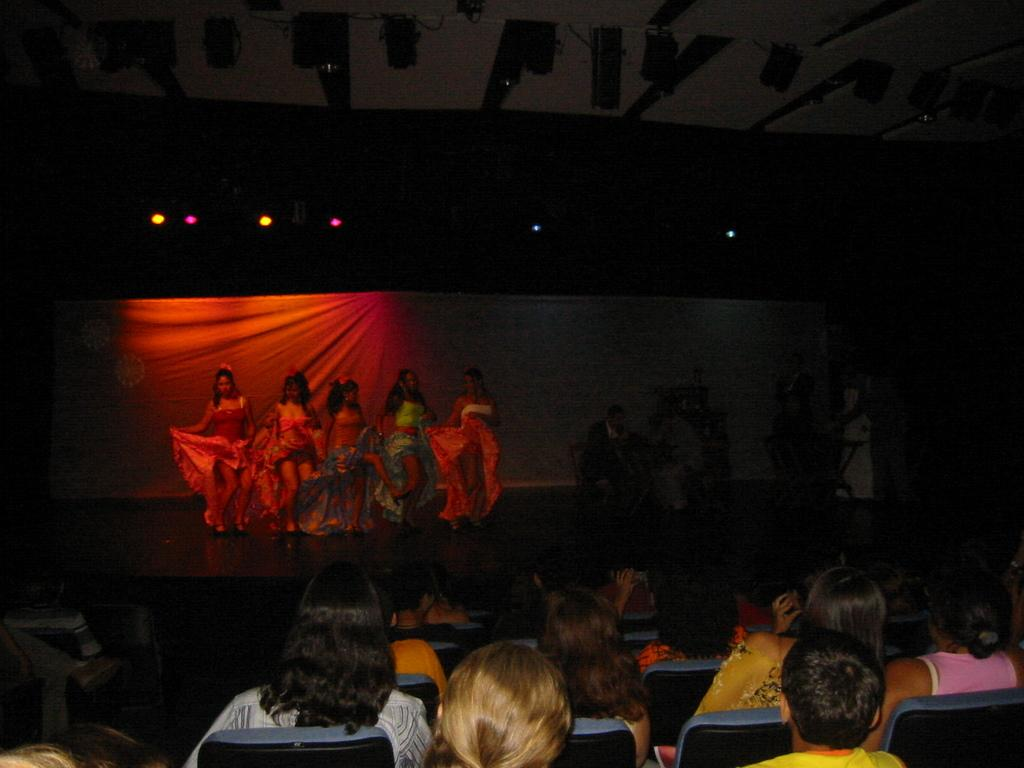What is happening in the image involving a group of people? There is a group of people in the image, with some seated on chairs and others dancing on a stage. Can you describe the seating arrangement in the image? Some people are seated on chairs in the image. What activity are the people on the stage engaged in? The people on the stage are dancing. What can be seen in the image that provides illumination? There are lights visible in the image. What type of pancake is being served on the roof in the image? There is no roof or pancake present in the image. 